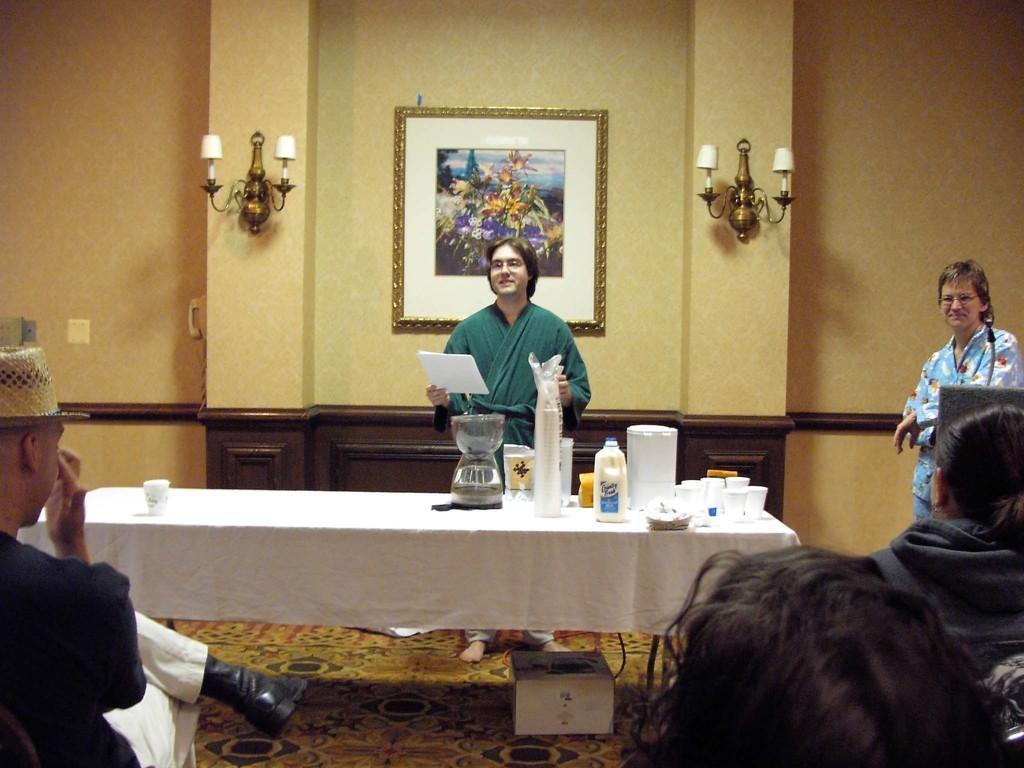How would you summarize this image in a sentence or two? In this picture there is a man standing in front of the table, holding a paper in his right hand. There is another person to the left of him, there are some more people sitting in the front of him. In the backdrop there are lights and a photo frame placed on the wall. 